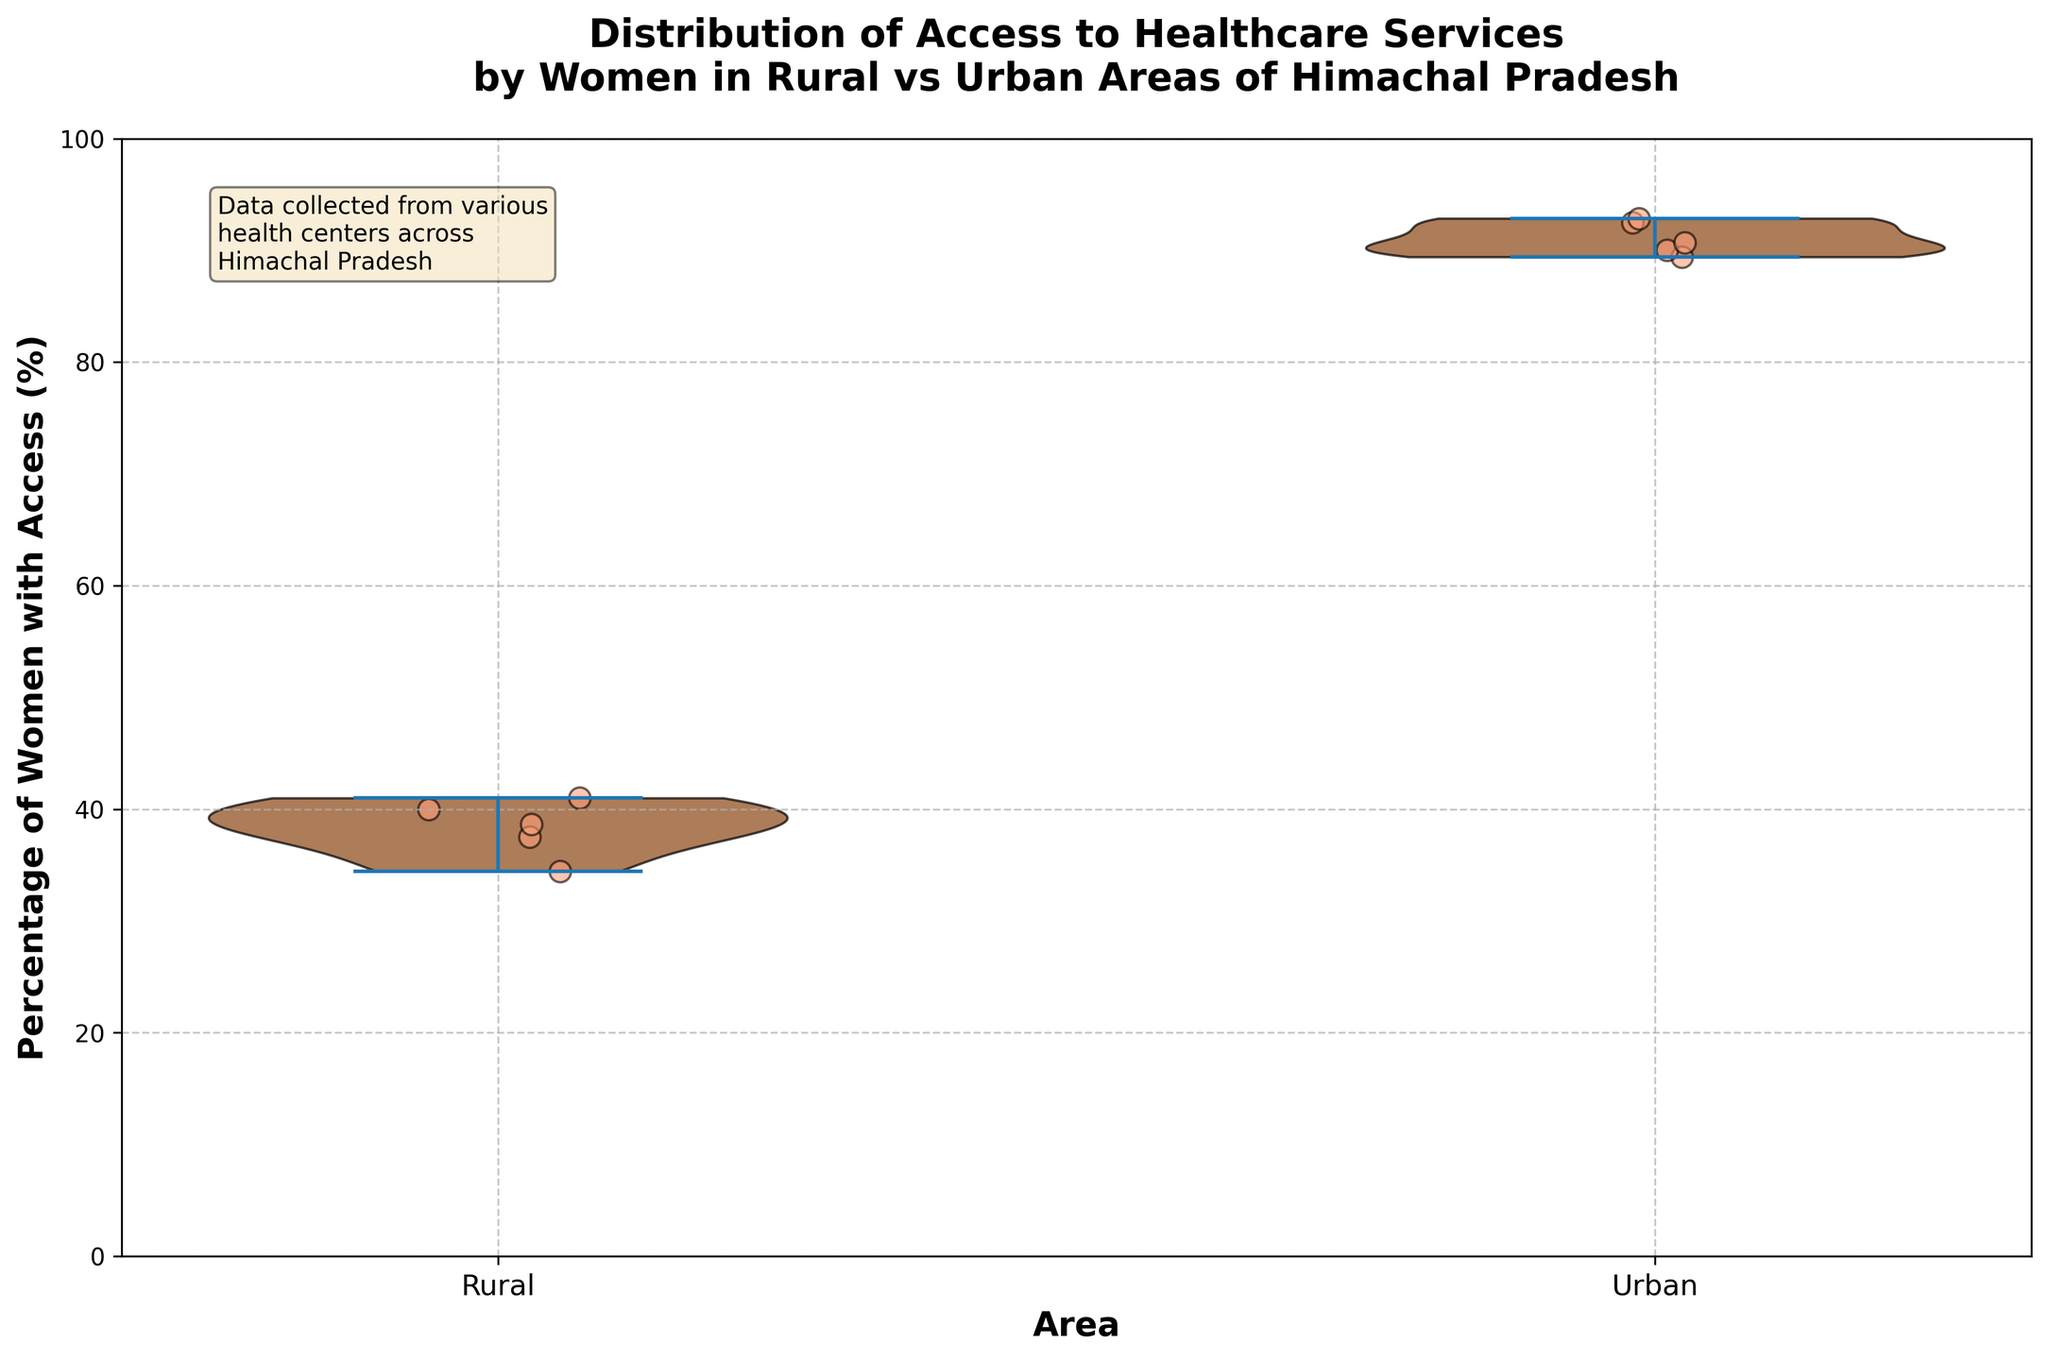What is the title of the figure? The title of the figure is mentioned at the top of the plot in bold. It reads, "Distribution of Access to Healthcare Services by Women in Rural vs Urban Areas of Himachal Pradesh".
Answer: Distribution of Access to Healthcare Services by Women in Rural vs Urban Areas of Himachal Pradesh How many different areas are represented on the x-axis? The x-axis has labels for the different areas represented. There are two distinct areas: "Rural" and "Urban".
Answer: 2 What is the range of the y-axis? The y-axis is labeled with values and ranges from 0 to 100, representing the percentage of women with access to healthcare services.
Answer: 0 to 100 Which area shows a higher average percentage of women with access to healthcare services? By observing the distribution and the locations of the jittered points, it's apparent that the urban area generally has higher percentages clustered towards the top.
Answer: Urban What percentage represents the lowest access to healthcare services in rural areas? From the scatter points, the lowest percentage in rural areas appears to be around the 35-40% mark.
Answer: Around 35-40% What is the relative density of women with access to healthcare services in urban areas? The density is represented by the width of the violin plots. The urban areas have a more concentrated distribution, suggesting a higher percentage of women with better access.
Answer: More concentrated at higher percentages Compare the spread of the distribution between the rural and urban areas. The spread or range of the distribution can be observed from the extent of the violin plots. The rural area has a wider spread, indicating more variability in access percentages. The urban area has a narrower, more concentrated spread around higher values.
Answer: Rural has wider spread, urban is more concentrated How many data points are there approximately in the rural area? By counting the jittered points within the rural section of the plot, there are approximately 5 data points.
Answer: 5 What insight does the text box provide? The text box provides context for the data, explaining that the data was collected from various health centers across Himachal Pradesh.
Answer: Data from various health centers Is there any visual indication of the mean or median in this plot? The violin plot and jittered points display the distribution but do not explicitly show the mean or median values visually.
Answer: No 